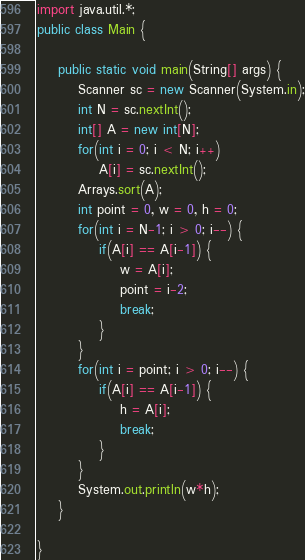Convert code to text. <code><loc_0><loc_0><loc_500><loc_500><_Java_>import java.util.*;
public class Main {

	public static void main(String[] args) {
		Scanner sc = new Scanner(System.in);
		int N = sc.nextInt();
		int[] A = new int[N];
		for(int i = 0; i < N; i++)
			A[i] = sc.nextInt();
		Arrays.sort(A);
		int point = 0, w = 0, h = 0;
		for(int i = N-1; i > 0; i--) {
			if(A[i] == A[i-1]) {
				w = A[i];
				point = i-2;
				break;
			}
		}
		for(int i = point; i > 0; i--) {
			if(A[i] == A[i-1]) {
				h = A[i];
				break;
			}
		}
		System.out.println(w*h);
	}

}</code> 